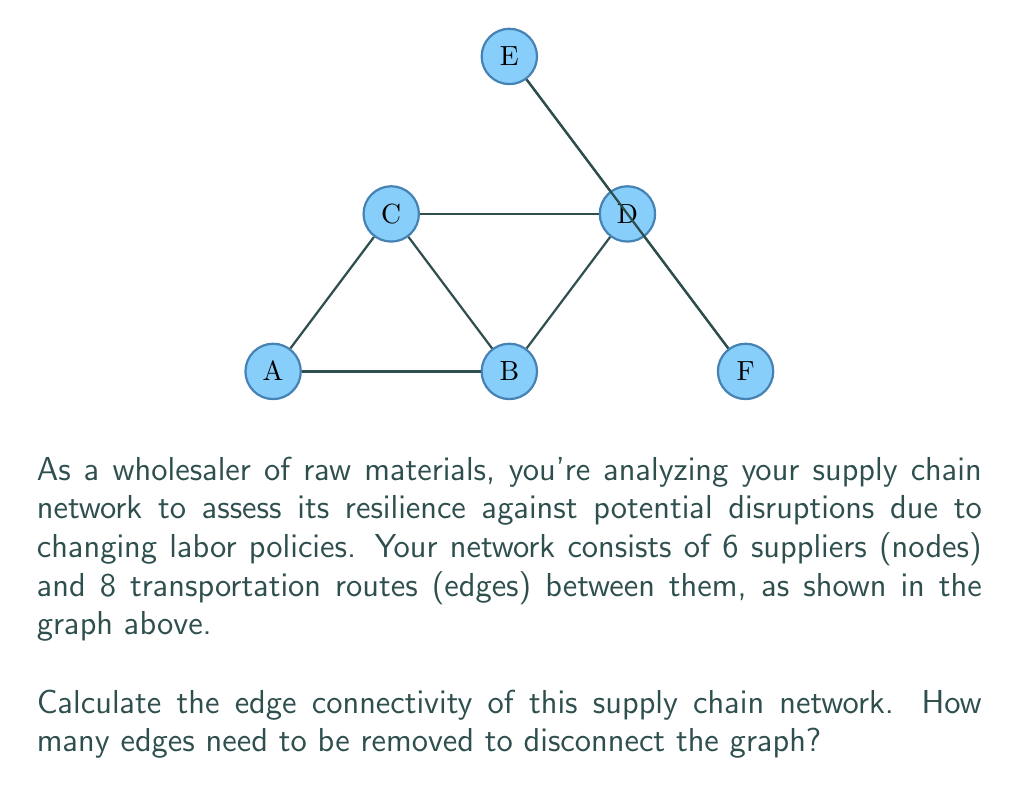Show me your answer to this math problem. To solve this problem, we need to understand the concept of edge connectivity in graph theory and apply it to our supply chain network.

1) Edge connectivity is defined as the minimum number of edges that need to be removed to disconnect the graph.

2) To find the edge connectivity, we need to identify the minimum cut set of the graph.

3) Let's analyze the graph systematically:

   a) Removing edges A-B and A-C disconnects node A from the rest of the graph.
   b) Removing edges B-C and B-D disconnects nodes A, B, and C from D, E, and F.
   c) Removing edges C-D and D-E disconnects node E from the rest of the graph.
   d) Removing edges D-E and D-F disconnects nodes E and F from A, B, C, and D.

4) Among these cuts, the smallest one requires removing 2 edges.

5) We can verify that there's no way to disconnect the graph by removing just one edge.

6) Therefore, the edge connectivity of this supply chain network is 2.

This means that the network can withstand the loss of any single transportation route without becoming disconnected, but losing two critical routes could potentially split the supply chain.
Answer: 2 